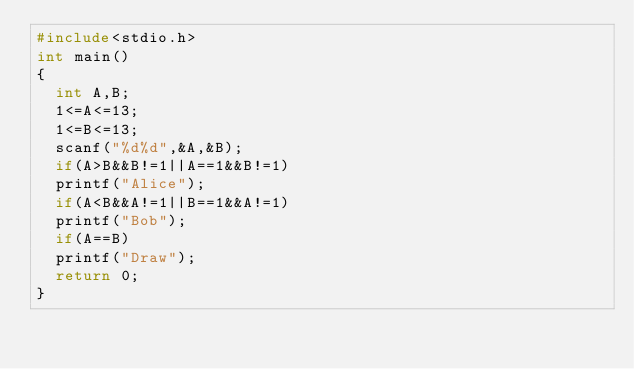<code> <loc_0><loc_0><loc_500><loc_500><_C++_>#include<stdio.h>
int main()
{
	int A,B;
	1<=A<=13;
	1<=B<=13;
	scanf("%d%d",&A,&B);
	if(A>B&&B!=1||A==1&&B!=1)
	printf("Alice");
	if(A<B&&A!=1||B==1&&A!=1)
	printf("Bob");
	if(A==B)
	printf("Draw");
	return 0;
}</code> 